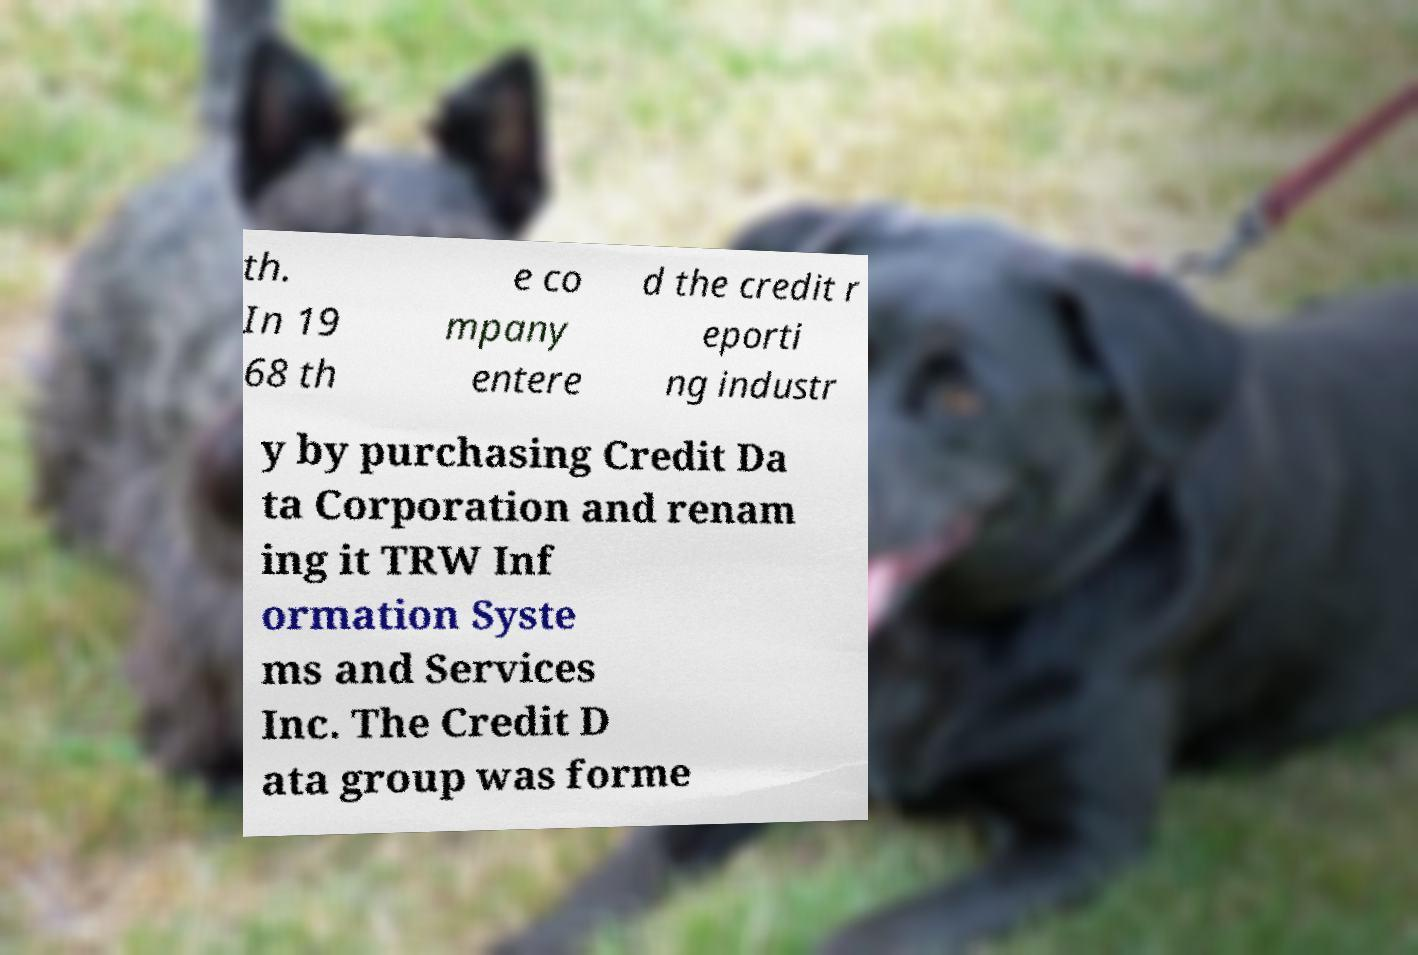Could you extract and type out the text from this image? th. In 19 68 th e co mpany entere d the credit r eporti ng industr y by purchasing Credit Da ta Corporation and renam ing it TRW Inf ormation Syste ms and Services Inc. The Credit D ata group was forme 